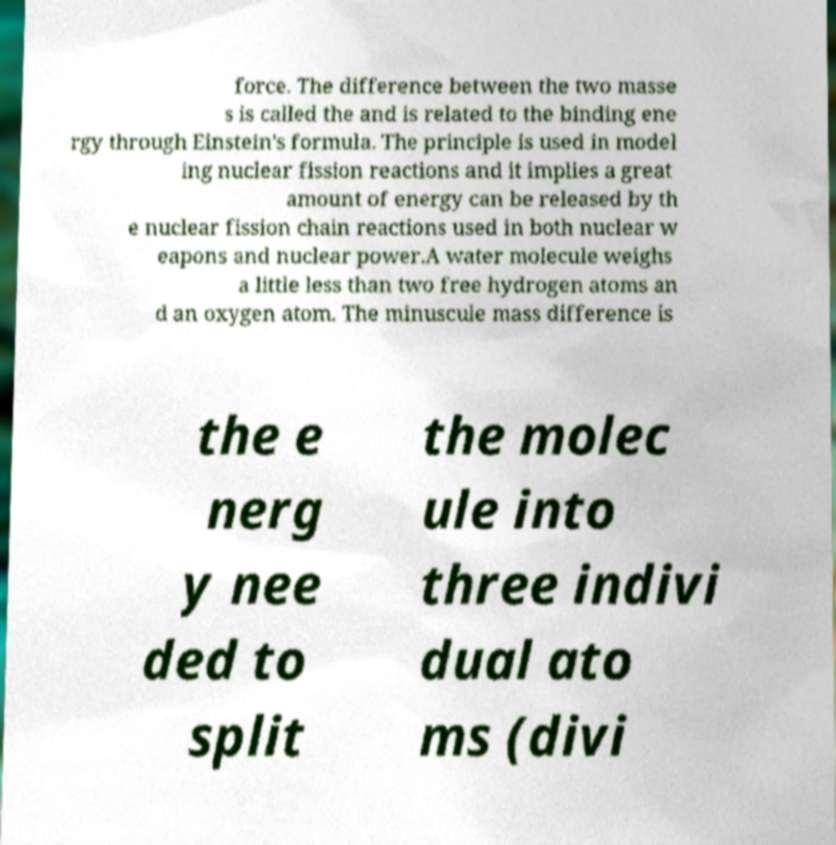Please identify and transcribe the text found in this image. force. The difference between the two masse s is called the and is related to the binding ene rgy through Einstein's formula. The principle is used in model ing nuclear fission reactions and it implies a great amount of energy can be released by th e nuclear fission chain reactions used in both nuclear w eapons and nuclear power.A water molecule weighs a little less than two free hydrogen atoms an d an oxygen atom. The minuscule mass difference is the e nerg y nee ded to split the molec ule into three indivi dual ato ms (divi 